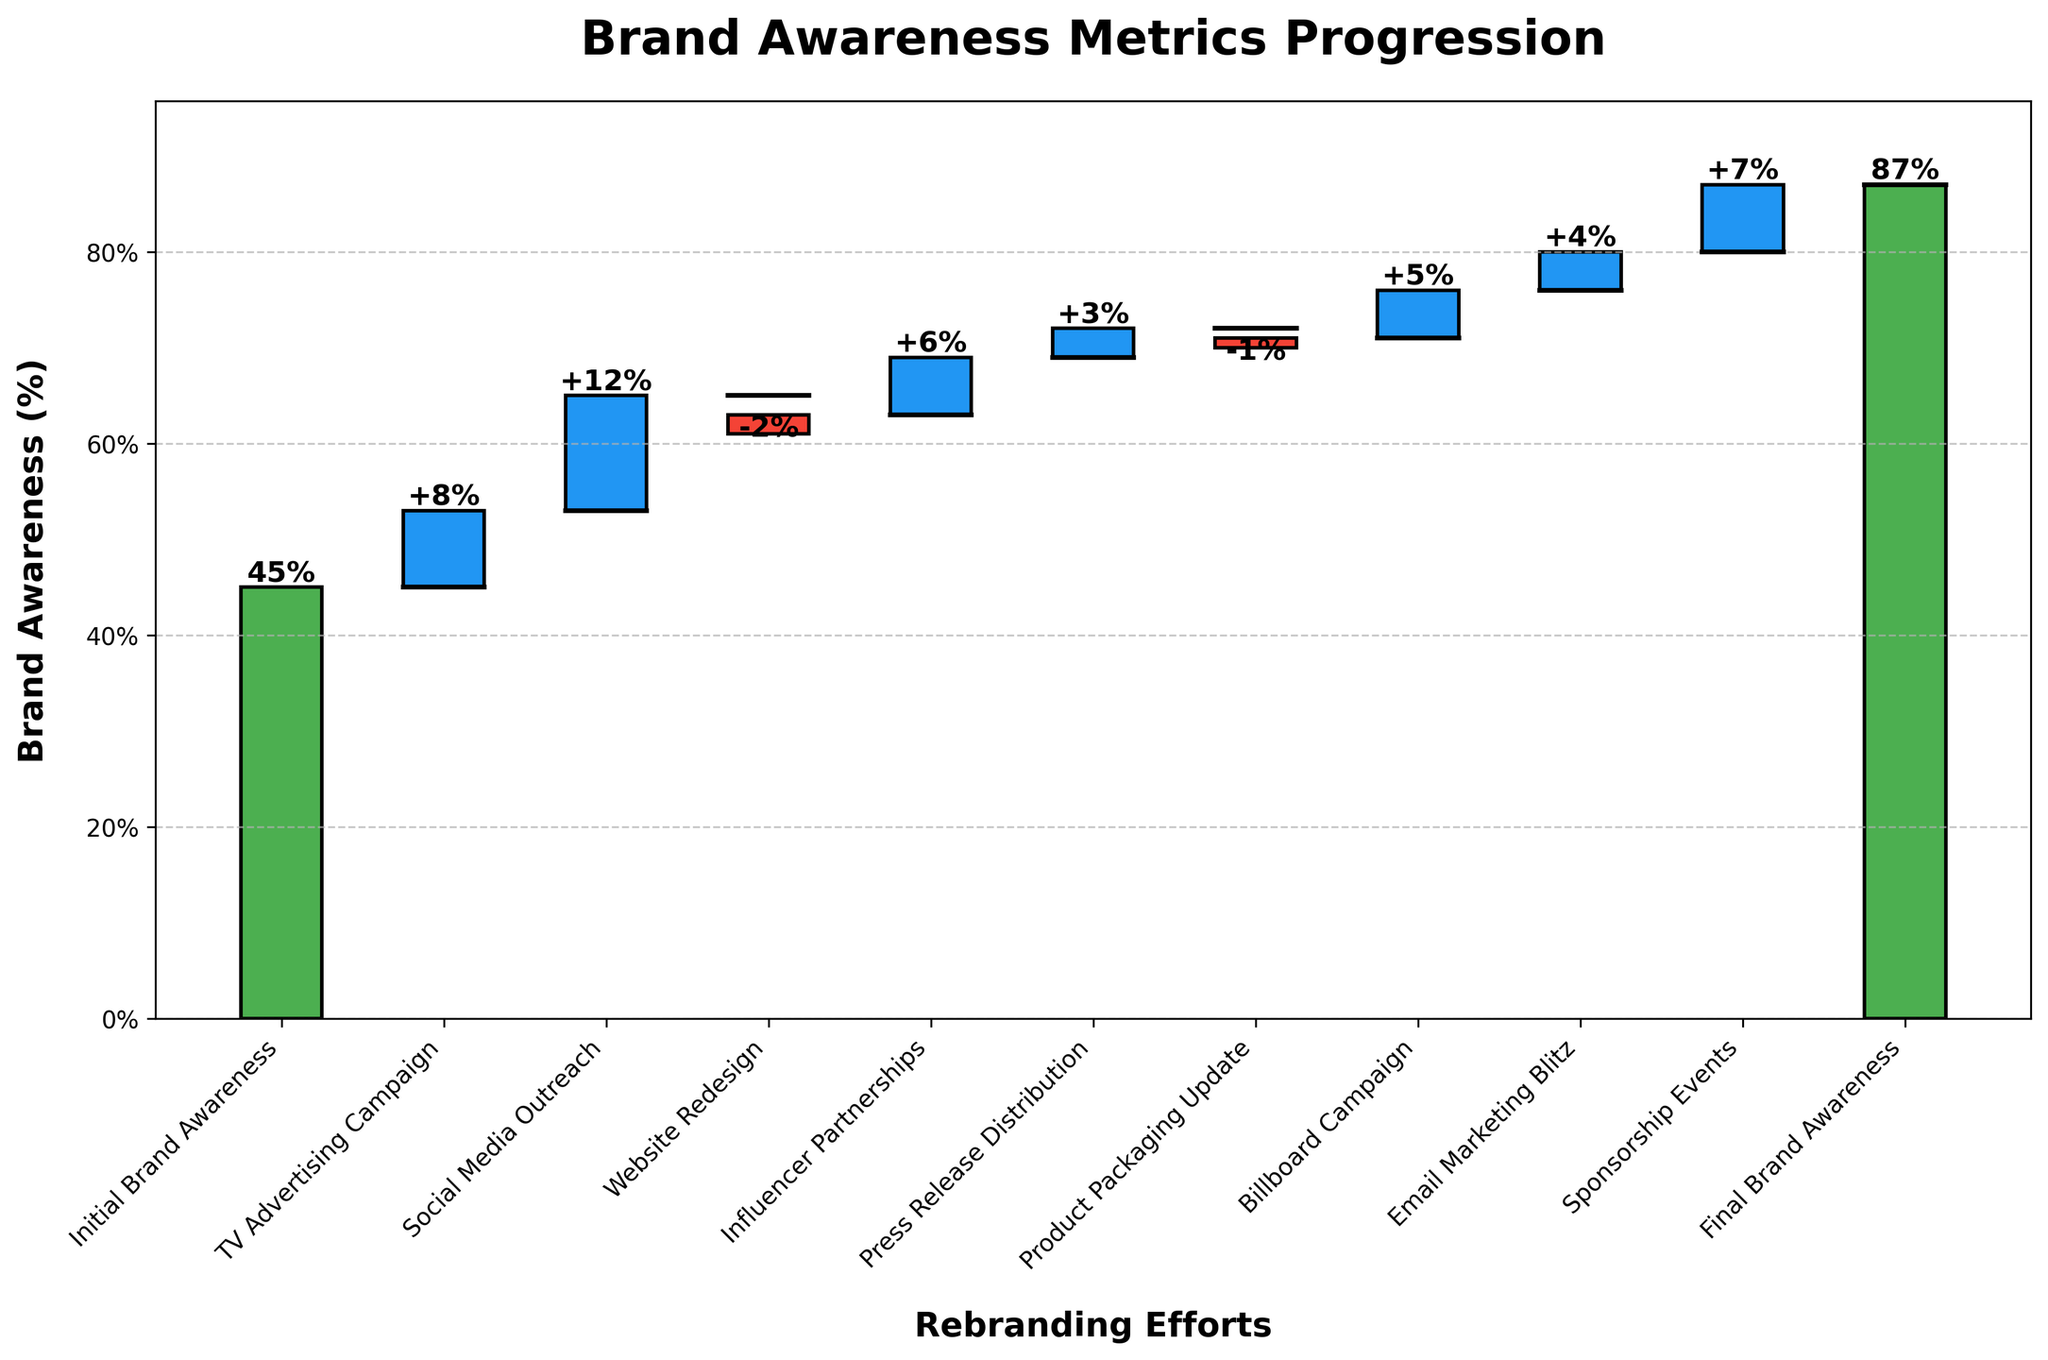What is the initial brand awareness percentage? The initial brand awareness percentage is shown as a green bar on the left with the label "Initial Brand Awareness" and a value indicator. It directly states the initial brand awareness.
Answer: 45% What is the final brand awareness percentage after all rebranding efforts? The final brand awareness percentage is shown as the last green bar on the right labeled "Final Brand Awareness." This bar shows the concluding brand awareness value.
Answer: 87% How much did the TV advertising campaign contribute to brand awareness? The TV advertising campaign's contribution to brand awareness is shown as a blue bar labeled "TV Advertising Campaign" with a positive value indicating its contribution.
Answer: 8% What are the categories that negatively impacted brand awareness? The categories that negatively impacted brand awareness are represented by red bars with negative values. Identifying these bars provides the answer.
Answer: Website Redesign, Product Packaging Update What is the combined positive contribution of Social Media Outreach and Influencer Partnerships? The positive contributions need to be summed up. Social Media Outreach contributed 12% and Influencer Partnerships contributed 6%, so the combined contribution is 12 + 6.
Answer: 18% Which effort yielded the highest increase in brand awareness? The height of blue bars indicates the increase in brand awareness. By comparing the blue bars, we find the tallest one for the highest increase.
Answer: Social Media Outreach Compare the contributions of Email Marketing Blitz and Sponsorship Events. Which one contributed more, and by how much? The blue bar heights labeled "Email Marketing Blitz" and "Sponsorship Events" indicate their contributions. Subtract the smaller value from the larger one to find the difference.
Answer: Sponsorship Events contributed 3% more What is the total increase in brand awareness from all efforts except the initial and final states? Sum all the values from TV Advertising Campaign to Sponsorship Events, excluding the first and the last bars. Add up 8 + 12 - 2 + 6 + 3 - 1 + 5 + 4 + 7.
Answer: 42% What is the net gain in brand awareness from the start to the finish of the rebranding rollout? Subtract the initial brand awareness from the final brand awareness to calculate the net gain. This is 87% (final) - 45% (initial).
Answer: 42% Which efforts caused a decline in brand awareness, and what was the total negative impact? Identify and sum the values of red bars. The categories are Website Redesign (-2%) and Product Packaging Update (-1%). Adding these gives the total negative impact.
Answer: -3% 